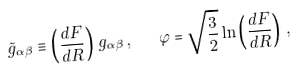<formula> <loc_0><loc_0><loc_500><loc_500>\tilde { g } _ { \alpha \beta } \equiv \left ( \frac { d F } { d R } \right ) \, g _ { \alpha \beta } \, { , } \quad \varphi = \sqrt { \frac { 3 } { 2 } } \ln \left ( \frac { d F } { d R } \right ) \, { , }</formula> 